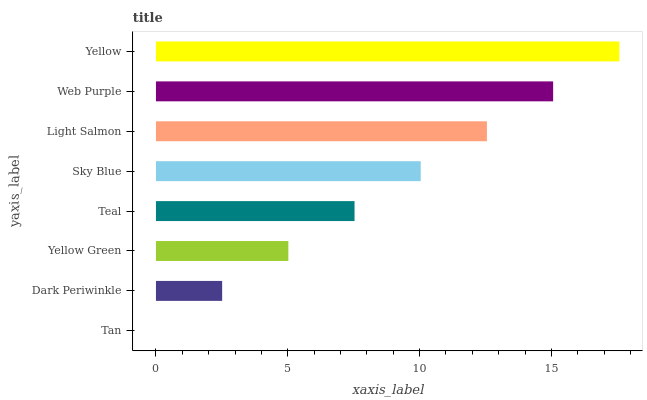Is Tan the minimum?
Answer yes or no. Yes. Is Yellow the maximum?
Answer yes or no. Yes. Is Dark Periwinkle the minimum?
Answer yes or no. No. Is Dark Periwinkle the maximum?
Answer yes or no. No. Is Dark Periwinkle greater than Tan?
Answer yes or no. Yes. Is Tan less than Dark Periwinkle?
Answer yes or no. Yes. Is Tan greater than Dark Periwinkle?
Answer yes or no. No. Is Dark Periwinkle less than Tan?
Answer yes or no. No. Is Sky Blue the high median?
Answer yes or no. Yes. Is Teal the low median?
Answer yes or no. Yes. Is Tan the high median?
Answer yes or no. No. Is Dark Periwinkle the low median?
Answer yes or no. No. 